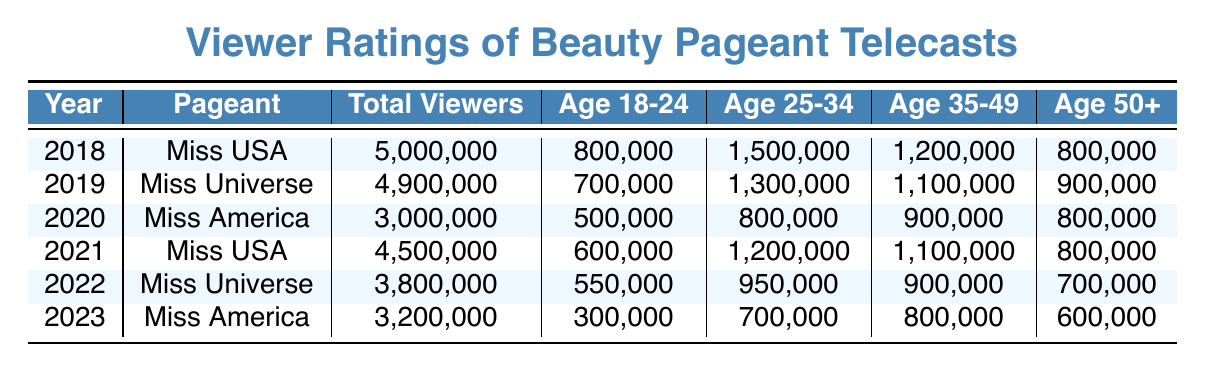What was the total viewership for Miss USA in 2018? The table states that the total viewers for Miss USA in 2018 was 5,000,000.
Answer: 5,000,000 Which age demographic had the highest number of viewers for Miss America in 2020? The number of viewers for each age demographic in 2020 is listed. Age 35-49 had the highest number of viewers with 900,000.
Answer: Age 35-49 What was the difference in total viewers between Miss Universe in 2019 and Miss Universe in 2022? The total viewers for Miss Universe in 2019 is 4,900,000 and in 2022 it is 3,800,000. The difference is 4,900,000 - 3,800,000 = 1,100,000.
Answer: 1,100,000 Did the total viewers for Miss America increase or decrease from 2020 to 2023? The total viewers for Miss America in 2020 is 3,000,000, while in 2023 it is 3,200,000. Since 3,200,000 is greater than 3,000,000, it indicates an increase.
Answer: Increase What was the average number of viewers in the age demographic 25-34 across all pageants from 2018 to 2023? The age 25-34 viewers are 1,500,000 in 2018, 1,300,000 in 2019, 800,000 in 2020, 1,200,000 in 2021, 950,000 in 2022, and 700,000 in 2023. Summing these gives 1,500,000 + 1,300,000 + 800,000 + 1,200,000 + 950,000 + 700,000 = 6,450,000. Dividing by 6 gives an average of 6,450,000 / 6 = 1,075,000.
Answer: 1,075,000 Which pageant had the least viewership in 2023? According to the table, the total viewership for Miss America in 2023 is 3,200,000, which is less than that of the other pageants in that year.
Answer: Miss America in 2023 Was the number of viewers in the age 18-24 demographic higher for Miss USA than Miss Universe in 2019? The viewers for Miss USA in 2018 were 800,000, and for Miss Universe in 2019 were 700,000. Since 800,000 is greater than 700,000, the viewers for Miss USA were indeed higher.
Answer: Yes What is the percentage change in total viewers for Miss USA from 2018 to 2021? The total viewers for Miss USA in 2018 is 5,000,000, and for 2021 it is 4,500,000. The change is (4,500,000 - 5,000,000) / 5,000,000 * 100 = -10%. This indicates a decrease of 10%.
Answer: -10% 